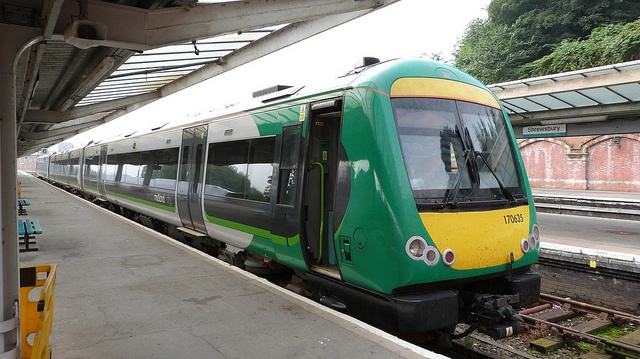Describe the objects in this image and their specific colors. I can see train in black, gray, darkgray, and teal tones, bench in black, gray, and darkgray tones, and bench in black, gray, and darkgray tones in this image. 